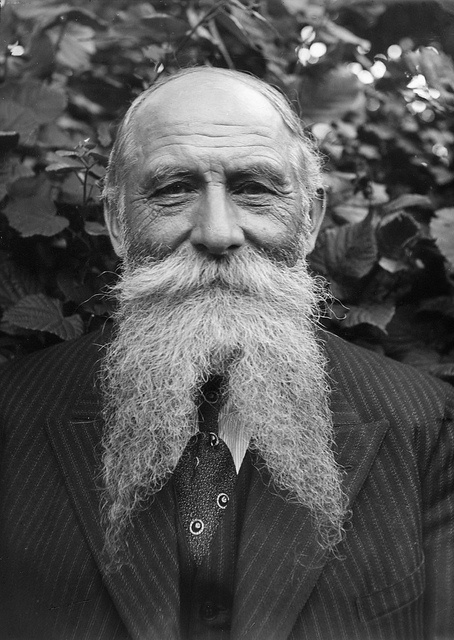Describe the objects in this image and their specific colors. I can see people in gray, black, darkgray, and lightgray tones and tie in gray, black, darkgray, and lightgray tones in this image. 